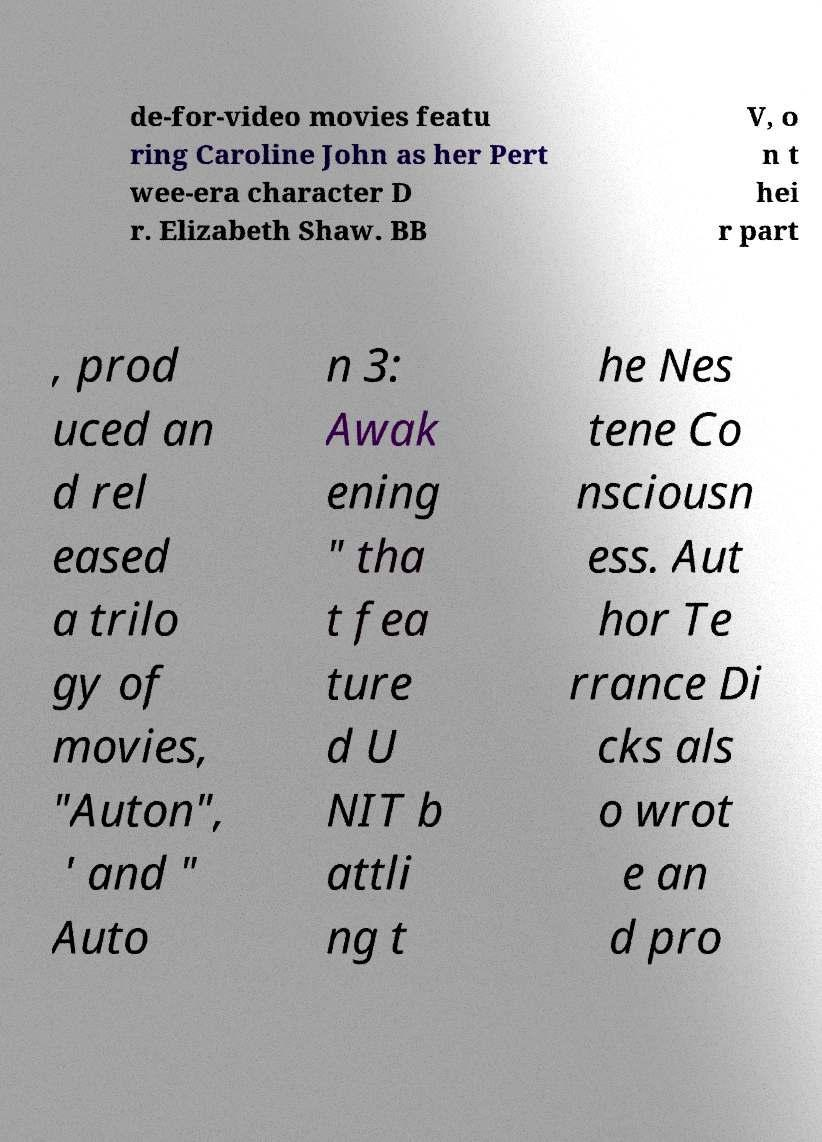Could you extract and type out the text from this image? de-for-video movies featu ring Caroline John as her Pert wee-era character D r. Elizabeth Shaw. BB V, o n t hei r part , prod uced an d rel eased a trilo gy of movies, "Auton", ' and " Auto n 3: Awak ening " tha t fea ture d U NIT b attli ng t he Nes tene Co nsciousn ess. Aut hor Te rrance Di cks als o wrot e an d pro 